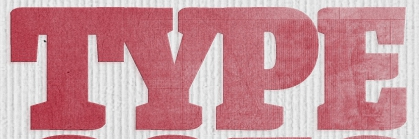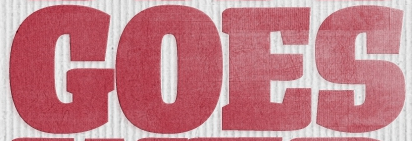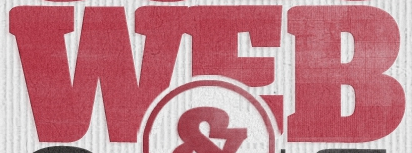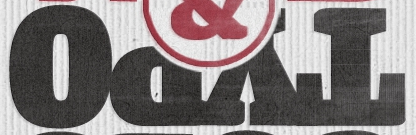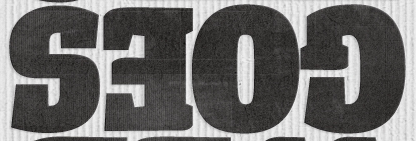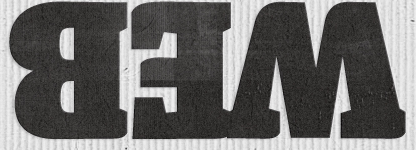Read the text from these images in sequence, separated by a semicolon. TYPE; GOES; WEB; TYPO; GOES; WEB 